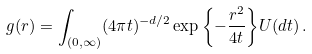<formula> <loc_0><loc_0><loc_500><loc_500>g ( r ) = \int _ { ( 0 , \infty ) } ( 4 \pi t ) ^ { - d / 2 } \exp { \left \{ - \frac { r ^ { 2 } } { 4 t } \right \} } U ( d t ) \, .</formula> 